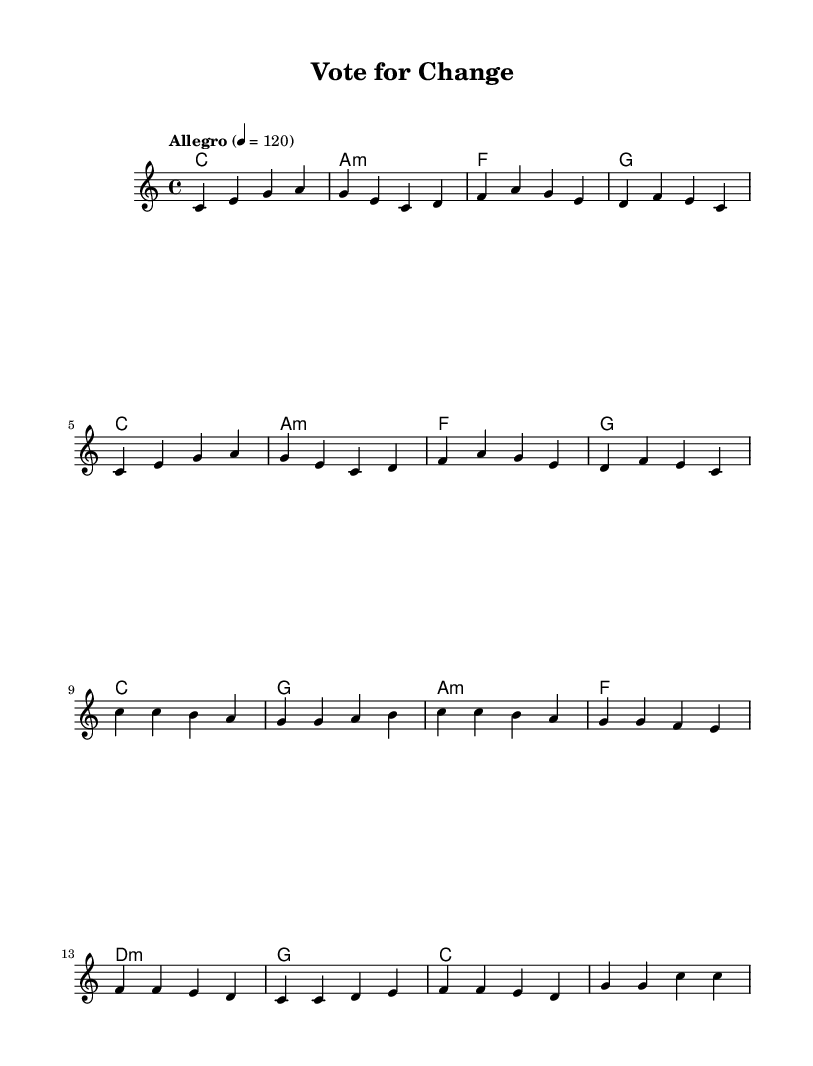What is the key signature of this music? The key signature indicated in the global section of the code is C major, which has no sharps or flats.
Answer: C major What is the time signature of this piece? The time signature is found in the global section as well and is noted as 4/4, which means there are four beats per measure.
Answer: 4/4 What is the tempo marking for this piece? The tempo marking is given in the global section with the term "Allegro," indicating a lively tempo, and is defined as 4 beats per minute at 120.
Answer: Allegro How many measures are there in the verse? By counting the measures in the melody section under “Verse,” there are 8 measures present.
Answer: 8 What is the first chord in the verse? The first chord in the harmonies section under "Verse" is C major, which is the first option listed.
Answer: C Which chords are used in the chorus? Looking at the harmonies section, the chords used in the chorus are C major, G major, A minor, and F major. These are identifiable in the order as listed in the code.
Answer: C, G, A minor, F What is the last note of the melody? The last note of the melody, as indicated in the melody section, is a C note, which is specified in the final measure.
Answer: C 